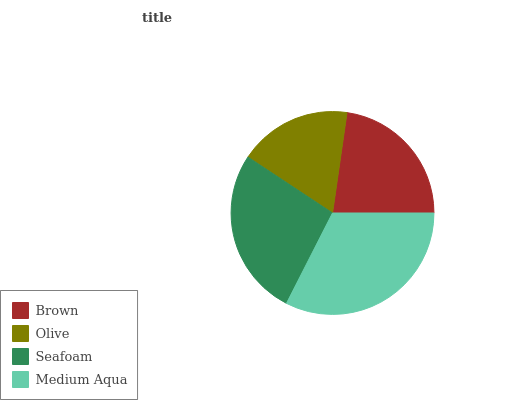Is Olive the minimum?
Answer yes or no. Yes. Is Medium Aqua the maximum?
Answer yes or no. Yes. Is Seafoam the minimum?
Answer yes or no. No. Is Seafoam the maximum?
Answer yes or no. No. Is Seafoam greater than Olive?
Answer yes or no. Yes. Is Olive less than Seafoam?
Answer yes or no. Yes. Is Olive greater than Seafoam?
Answer yes or no. No. Is Seafoam less than Olive?
Answer yes or no. No. Is Seafoam the high median?
Answer yes or no. Yes. Is Brown the low median?
Answer yes or no. Yes. Is Brown the high median?
Answer yes or no. No. Is Seafoam the low median?
Answer yes or no. No. 